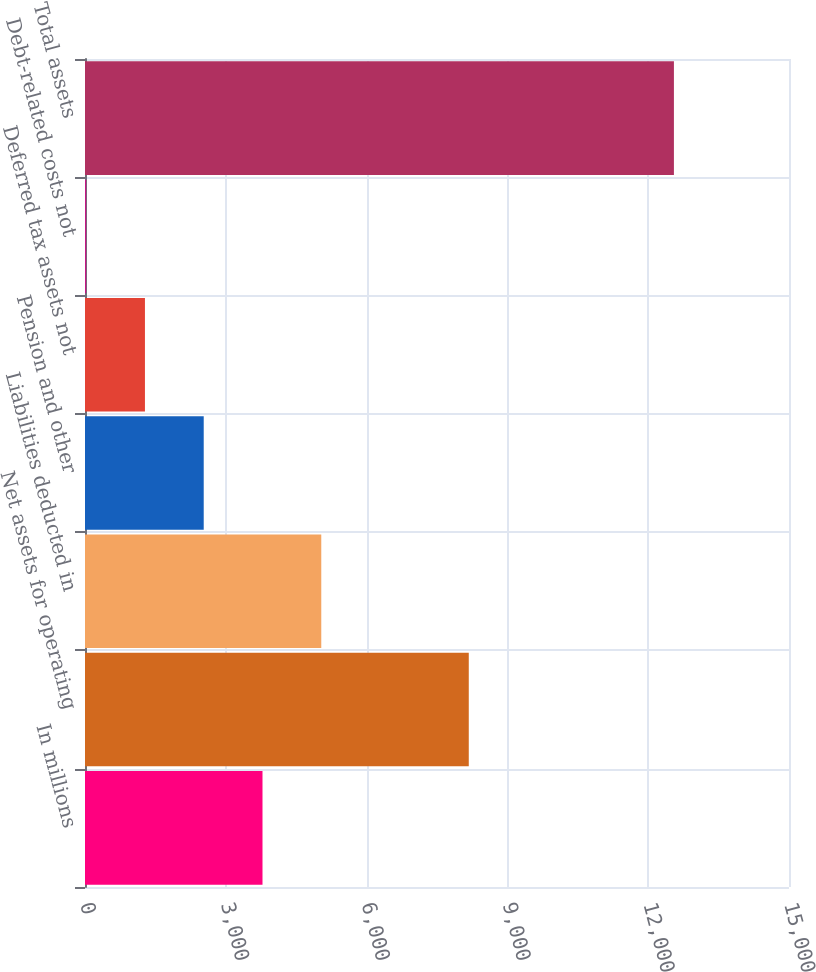Convert chart. <chart><loc_0><loc_0><loc_500><loc_500><bar_chart><fcel>In millions<fcel>Net assets for operating<fcel>Liabilities deducted in<fcel>Pension and other<fcel>Deferred tax assets not<fcel>Debt-related costs not<fcel>Total assets<nl><fcel>3781.9<fcel>8177<fcel>5034.2<fcel>2529.6<fcel>1277.3<fcel>25<fcel>12548<nl></chart> 